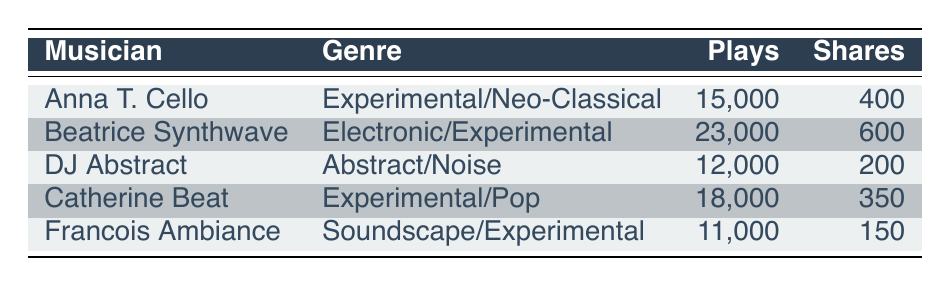What is the total number of plays for the featured musicians? To find the total number of plays, sum the plays for each musician: 15000 + 23000 + 12000 + 18000 + 11000 = 89000.
Answer: 89000 Which musician has the highest number of shares? By looking at the shares column, Beatrice Synthwave has the highest shares at 600.
Answer: Beatrice Synthwave How many more plays does Catherine Beat have compared to DJ Abstract? Catherine Beat has 18000 plays and DJ Abstract has 12000 plays. The difference is 18000 - 12000 = 6000.
Answer: 6000 Is it true that Francois Ambiance has more shares than Anna T. Cello? Francois Ambiance has 150 shares and Anna T. Cello has 400 shares. Since 150 < 400, the statement is false.
Answer: No What is the average number of plays among all featured musicians? To calculate the average, first sum the plays: 89000 (from the previous question). There are 5 musicians, so the average is 89000 / 5 = 17800.
Answer: 17800 Which musician has the lowest number of plays and what is that number? By inspecting the plays column, Francois Ambiance has the lowest plays at 11000.
Answer: 11000 How many total shares do Anna T. Cello and DJ Abstract have combined? Anna T. Cello has 400 shares and DJ Abstract has 200 shares. Adding them gives 400 + 200 = 600 shares.
Answer: 600 Are there more musicians in the Experimental genre than in the Electronic genre? There are 3 musicians (Anna T. Cello, Catherine Beat, and Francois Ambiance) in the Experimental genre and 1 musician (Beatrice Synthwave) in the Electronic genre. Thus, the answer is yes.
Answer: Yes What is the difference in shares between the musician with the most shares and the musician with the least? Beatrice Synthwave has the most shares (600) and Francois Ambiance has the least (150). The difference is 600 - 150 = 450.
Answer: 450 